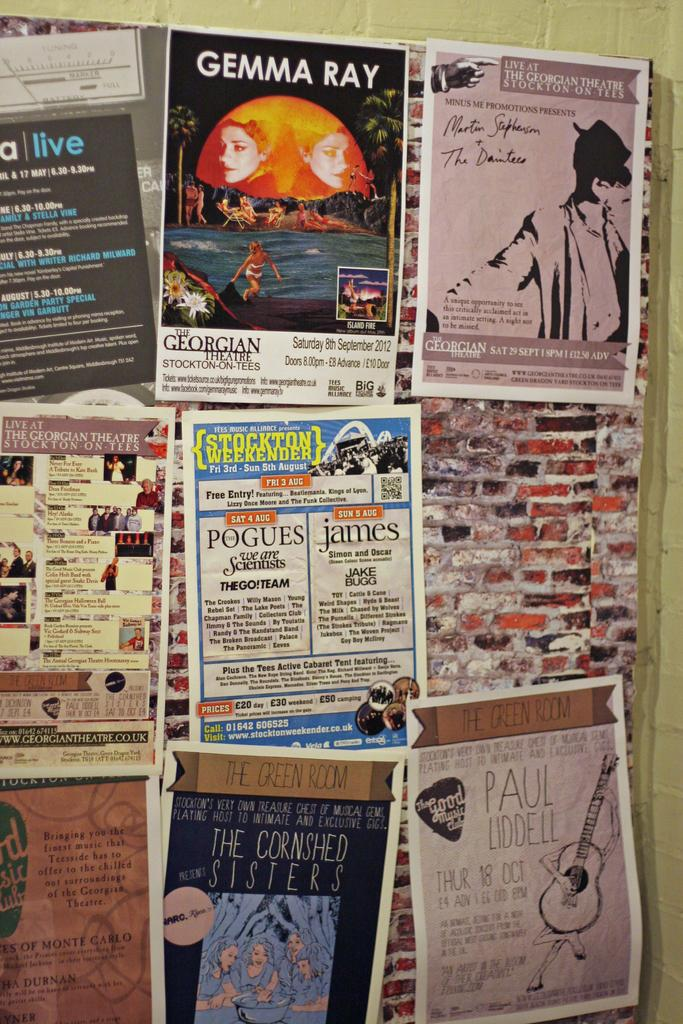Provide a one-sentence caption for the provided image. A bulletin board with multiple advertisements attached to it including one with info about Gemma Ray and Paul Liddell. 